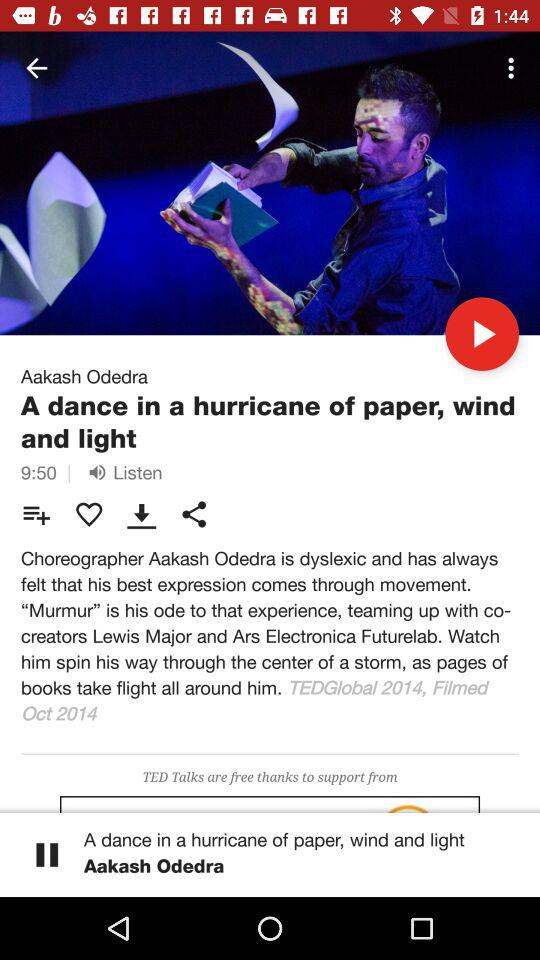Which TED Talk is currently playing? The TED Talk that is currently playing is "A dance in a hurricane of paper, wind and light". 